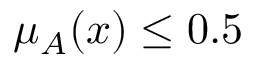<formula> <loc_0><loc_0><loc_500><loc_500>\mu _ { A } ( x ) \leq 0 . 5</formula> 